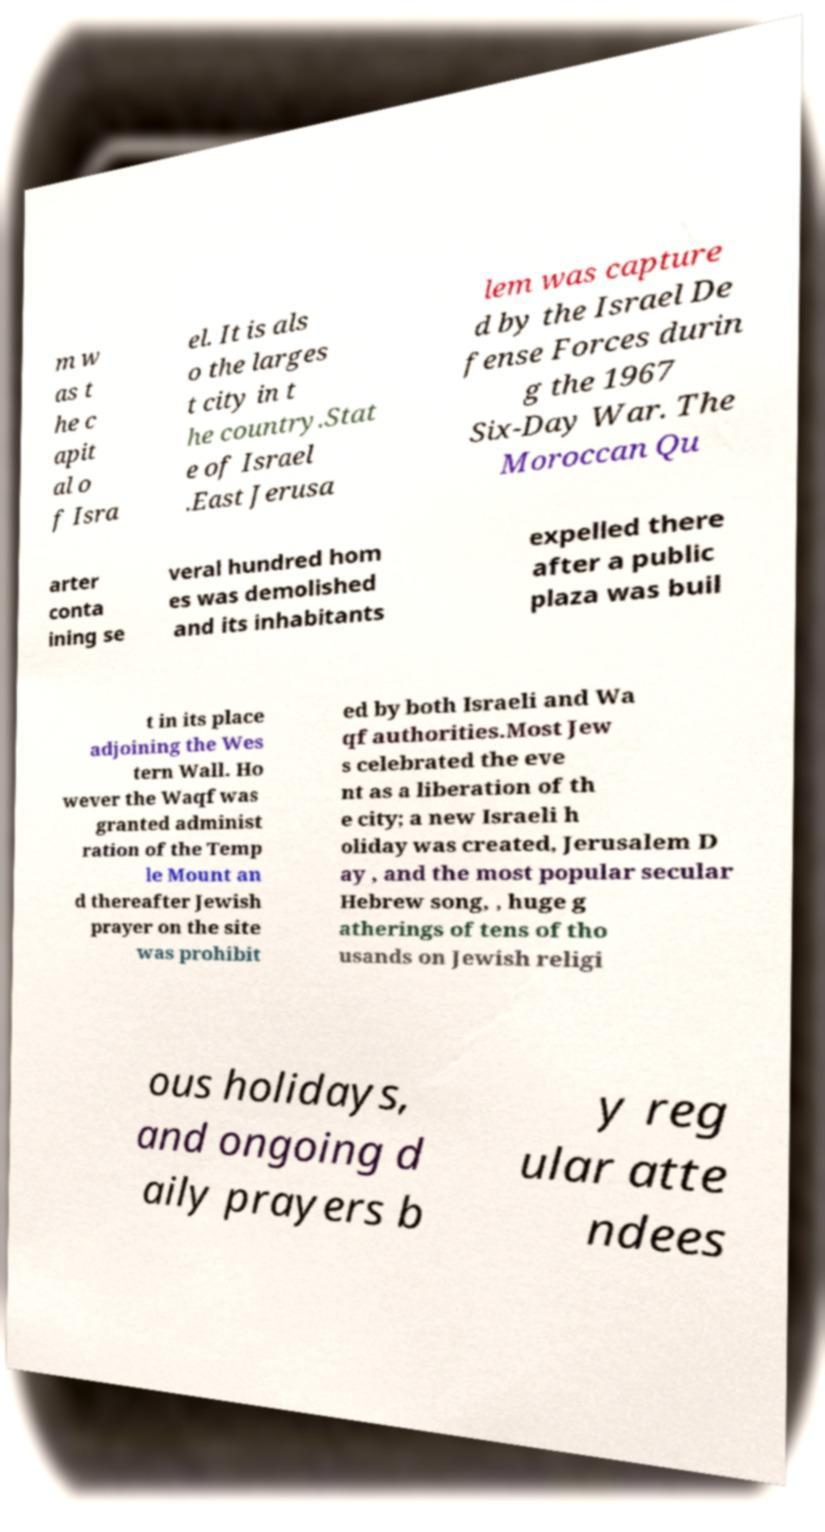Can you read and provide the text displayed in the image?This photo seems to have some interesting text. Can you extract and type it out for me? m w as t he c apit al o f Isra el. It is als o the larges t city in t he country.Stat e of Israel .East Jerusa lem was capture d by the Israel De fense Forces durin g the 1967 Six-Day War. The Moroccan Qu arter conta ining se veral hundred hom es was demolished and its inhabitants expelled there after a public plaza was buil t in its place adjoining the Wes tern Wall. Ho wever the Waqf was granted administ ration of the Temp le Mount an d thereafter Jewish prayer on the site was prohibit ed by both Israeli and Wa qf authorities.Most Jew s celebrated the eve nt as a liberation of th e city; a new Israeli h oliday was created, Jerusalem D ay , and the most popular secular Hebrew song, , huge g atherings of tens of tho usands on Jewish religi ous holidays, and ongoing d aily prayers b y reg ular atte ndees 